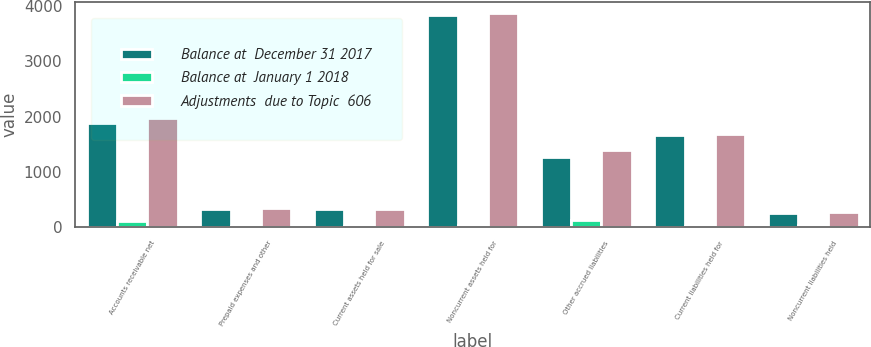<chart> <loc_0><loc_0><loc_500><loc_500><stacked_bar_chart><ecel><fcel>Accounts receivable net<fcel>Prepaid expenses and other<fcel>Current assets held for sale<fcel>Noncurrent assets held for<fcel>Other accrued liabilities<fcel>Current liabilities held for<fcel>Noncurrent liabilities held<nl><fcel>Balance at  December 31 2017<fcel>1879.3<fcel>327.9<fcel>327.9<fcel>3842.2<fcel>1271.9<fcel>1661.3<fcel>242.5<nl><fcel>Balance at  January 1 2018<fcel>100.3<fcel>14.6<fcel>21.3<fcel>33.8<fcel>114.9<fcel>21.3<fcel>33.8<nl><fcel>Adjustments  due to Topic  606<fcel>1979.6<fcel>342.5<fcel>327.9<fcel>3876<fcel>1386.8<fcel>1682.6<fcel>276.3<nl></chart> 